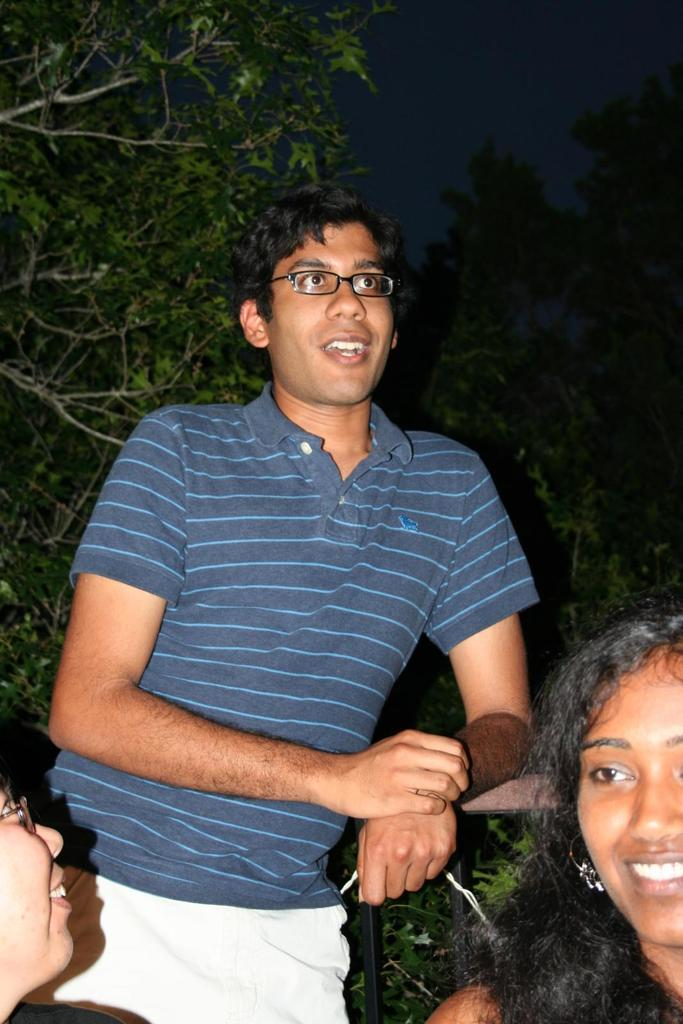What is the man in the image wearing? The man is wearing a t-shirt and shorts in the image. What can be seen on the man's face in the image? The man is wearing spectacles and is smiling in the image. What is the girl in the image doing? The girl is smiling in the image. What is visible on the left side of the image? There are trees on the left side of the image. What type of window can be seen in the image? There is no window present in the image. What angle is the image taken from? The angle from which the image is taken cannot be determined from the image itself. 